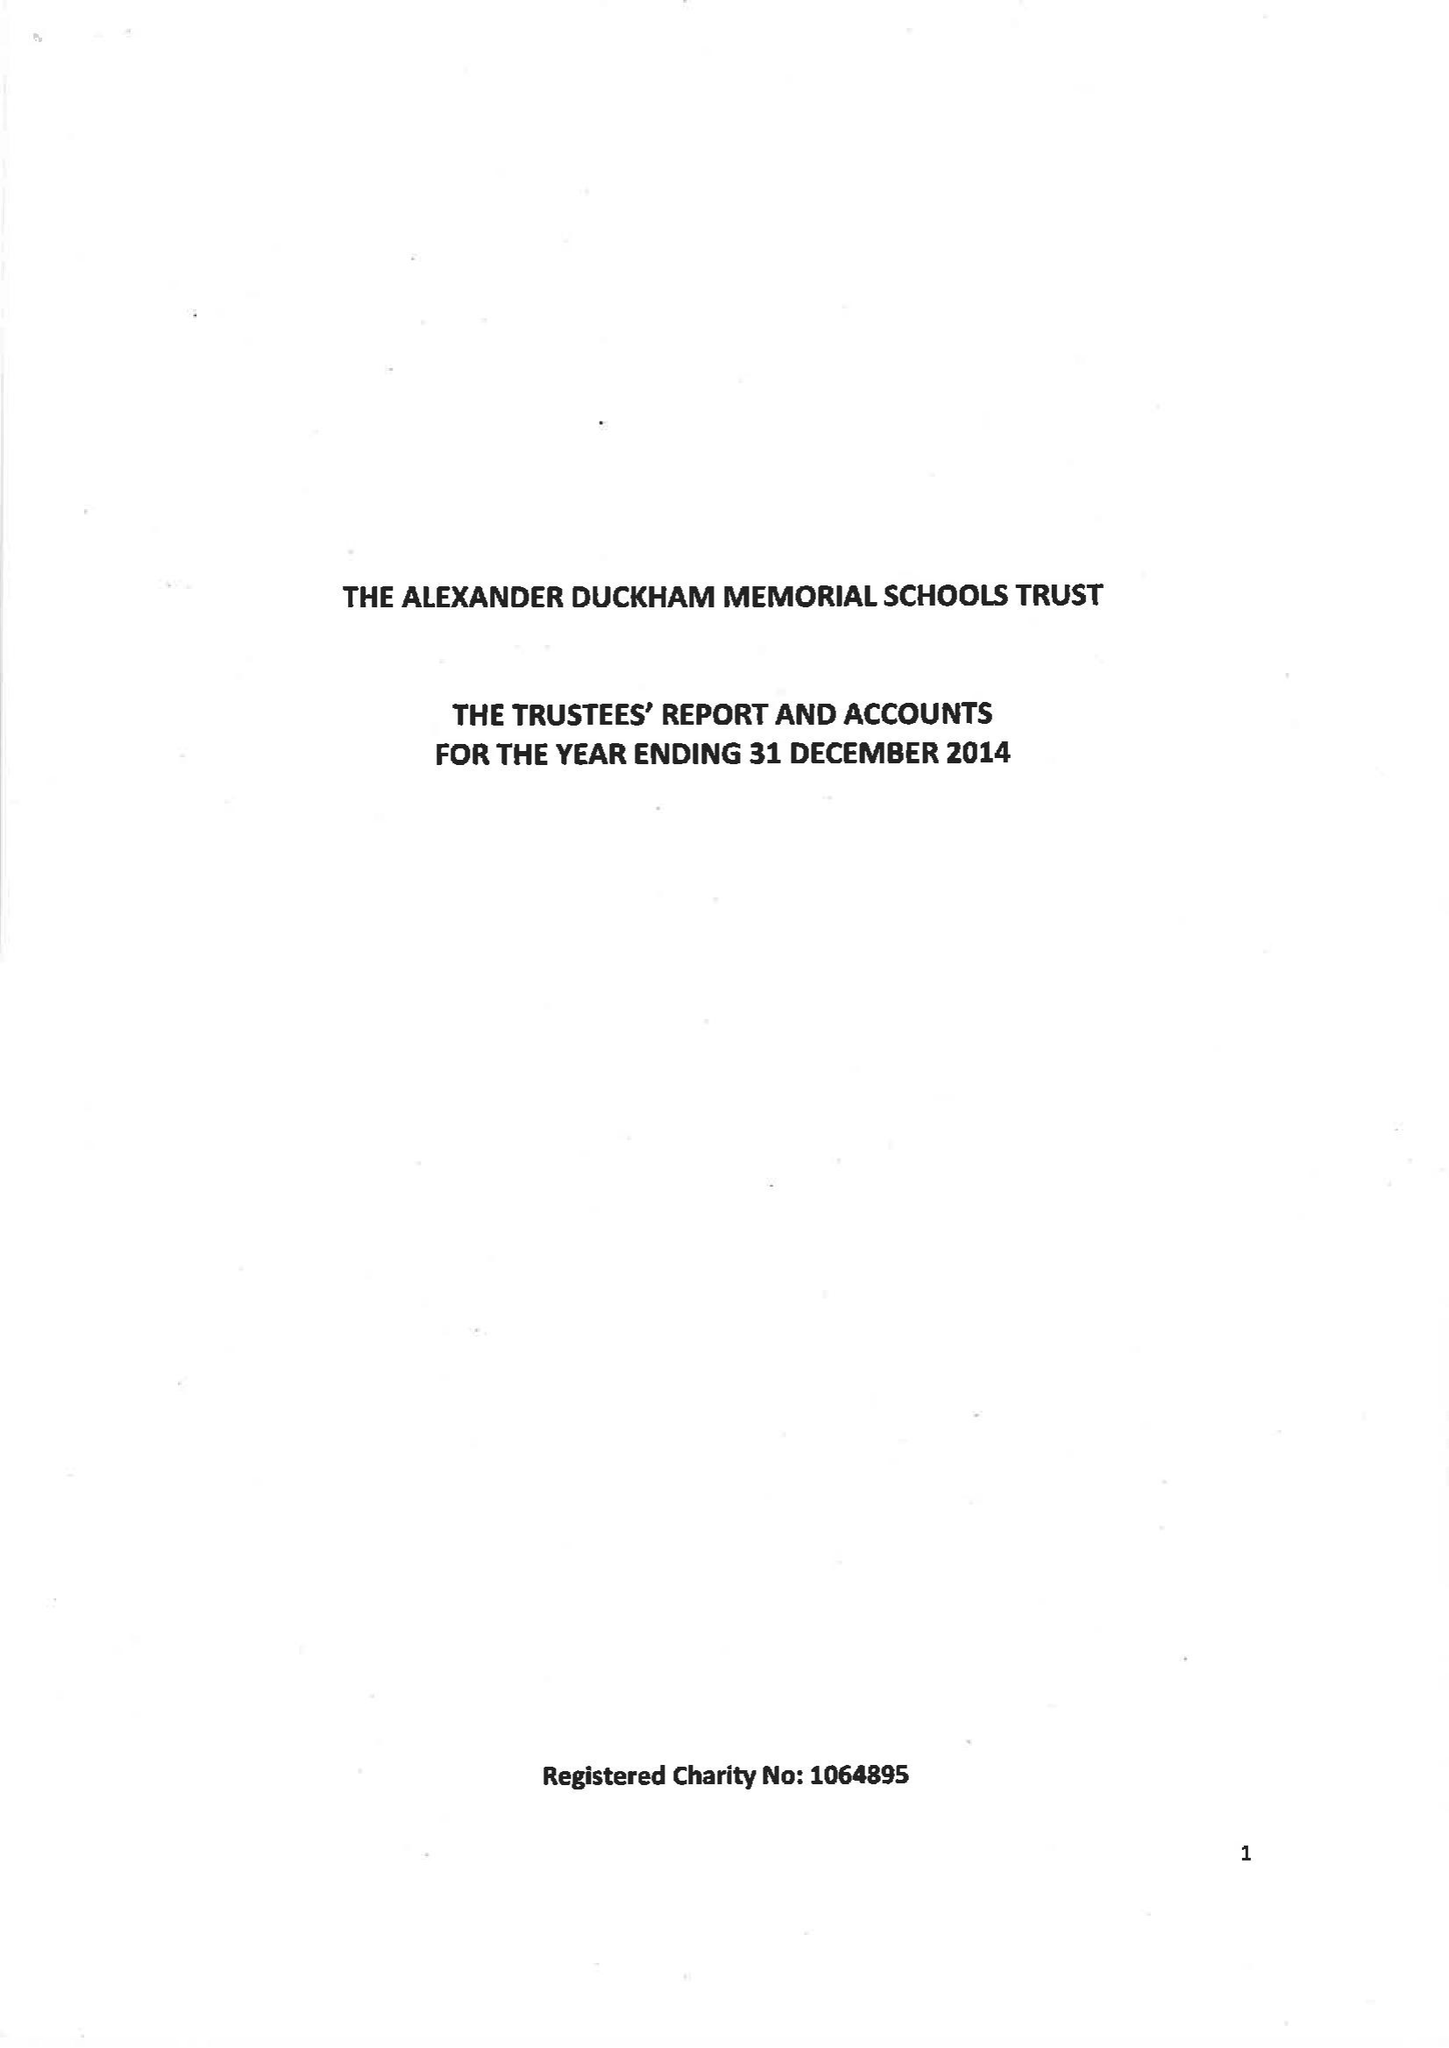What is the value for the report_date?
Answer the question using a single word or phrase. 2014-12-31 